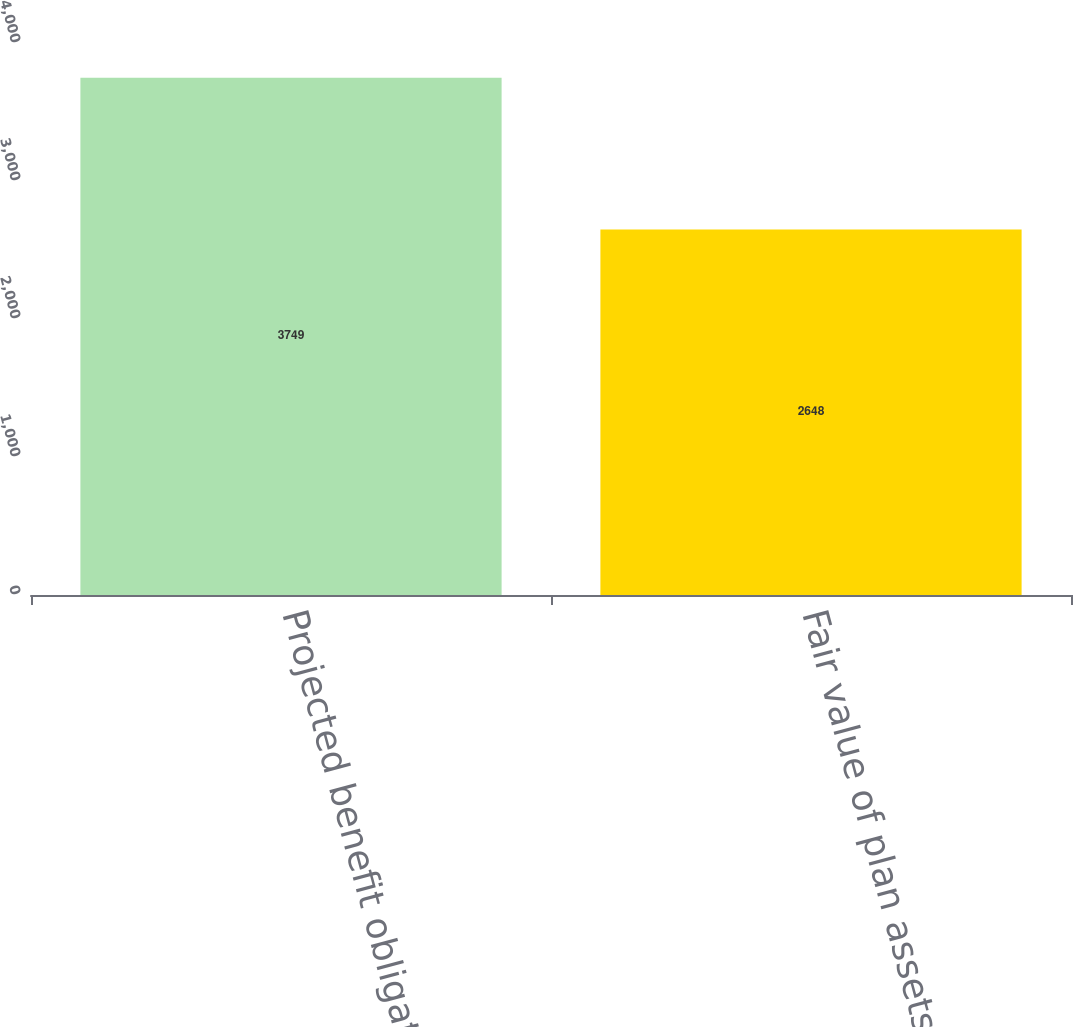Convert chart. <chart><loc_0><loc_0><loc_500><loc_500><bar_chart><fcel>Projected benefit obligation<fcel>Fair value of plan assets<nl><fcel>3749<fcel>2648<nl></chart> 